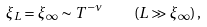Convert formula to latex. <formula><loc_0><loc_0><loc_500><loc_500>\xi _ { L } = \xi _ { \infty } \sim T ^ { - \nu } \quad ( L \gg \xi _ { \infty } ) \, ,</formula> 